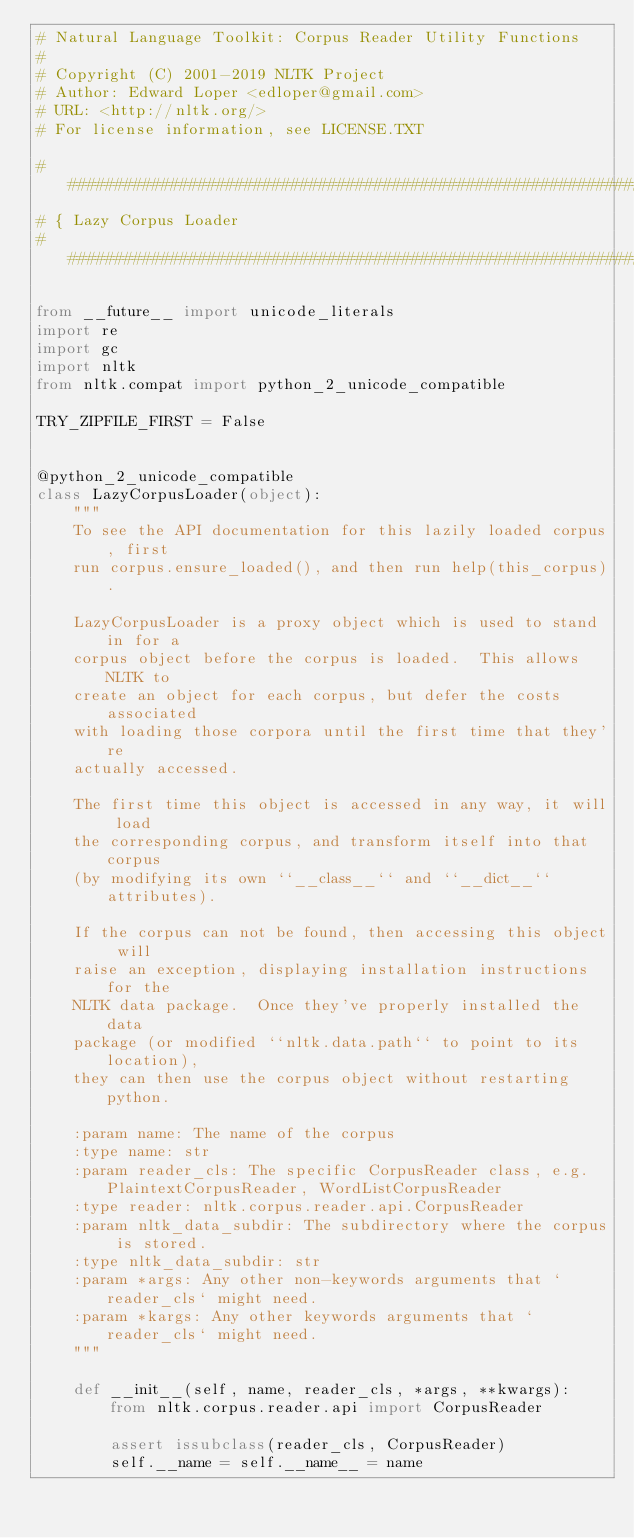<code> <loc_0><loc_0><loc_500><loc_500><_Python_># Natural Language Toolkit: Corpus Reader Utility Functions
#
# Copyright (C) 2001-2019 NLTK Project
# Author: Edward Loper <edloper@gmail.com>
# URL: <http://nltk.org/>
# For license information, see LICENSE.TXT

######################################################################
# { Lazy Corpus Loader
######################################################################

from __future__ import unicode_literals
import re
import gc
import nltk
from nltk.compat import python_2_unicode_compatible

TRY_ZIPFILE_FIRST = False


@python_2_unicode_compatible
class LazyCorpusLoader(object):
    """
    To see the API documentation for this lazily loaded corpus, first
    run corpus.ensure_loaded(), and then run help(this_corpus).

    LazyCorpusLoader is a proxy object which is used to stand in for a
    corpus object before the corpus is loaded.  This allows NLTK to
    create an object for each corpus, but defer the costs associated
    with loading those corpora until the first time that they're
    actually accessed.

    The first time this object is accessed in any way, it will load
    the corresponding corpus, and transform itself into that corpus
    (by modifying its own ``__class__`` and ``__dict__`` attributes).

    If the corpus can not be found, then accessing this object will
    raise an exception, displaying installation instructions for the
    NLTK data package.  Once they've properly installed the data
    package (or modified ``nltk.data.path`` to point to its location),
    they can then use the corpus object without restarting python.

    :param name: The name of the corpus
    :type name: str
    :param reader_cls: The specific CorpusReader class, e.g. PlaintextCorpusReader, WordListCorpusReader
    :type reader: nltk.corpus.reader.api.CorpusReader
    :param nltk_data_subdir: The subdirectory where the corpus is stored.
    :type nltk_data_subdir: str
    :param *args: Any other non-keywords arguments that `reader_cls` might need.
    :param *kargs: Any other keywords arguments that `reader_cls` might need.
    """

    def __init__(self, name, reader_cls, *args, **kwargs):
        from nltk.corpus.reader.api import CorpusReader

        assert issubclass(reader_cls, CorpusReader)
        self.__name = self.__name__ = name</code> 